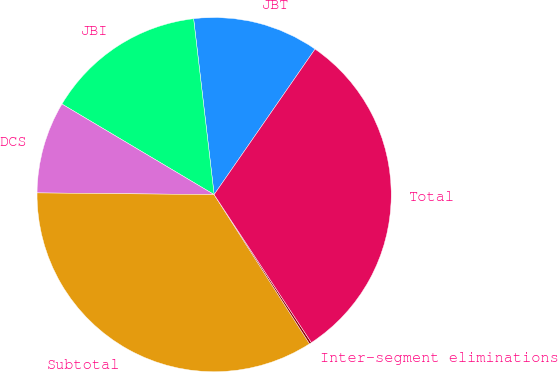<chart> <loc_0><loc_0><loc_500><loc_500><pie_chart><fcel>JBT<fcel>JBI<fcel>DCS<fcel>Subtotal<fcel>Inter-segment eliminations<fcel>Total<nl><fcel>11.5%<fcel>14.61%<fcel>8.39%<fcel>34.21%<fcel>0.2%<fcel>31.1%<nl></chart> 